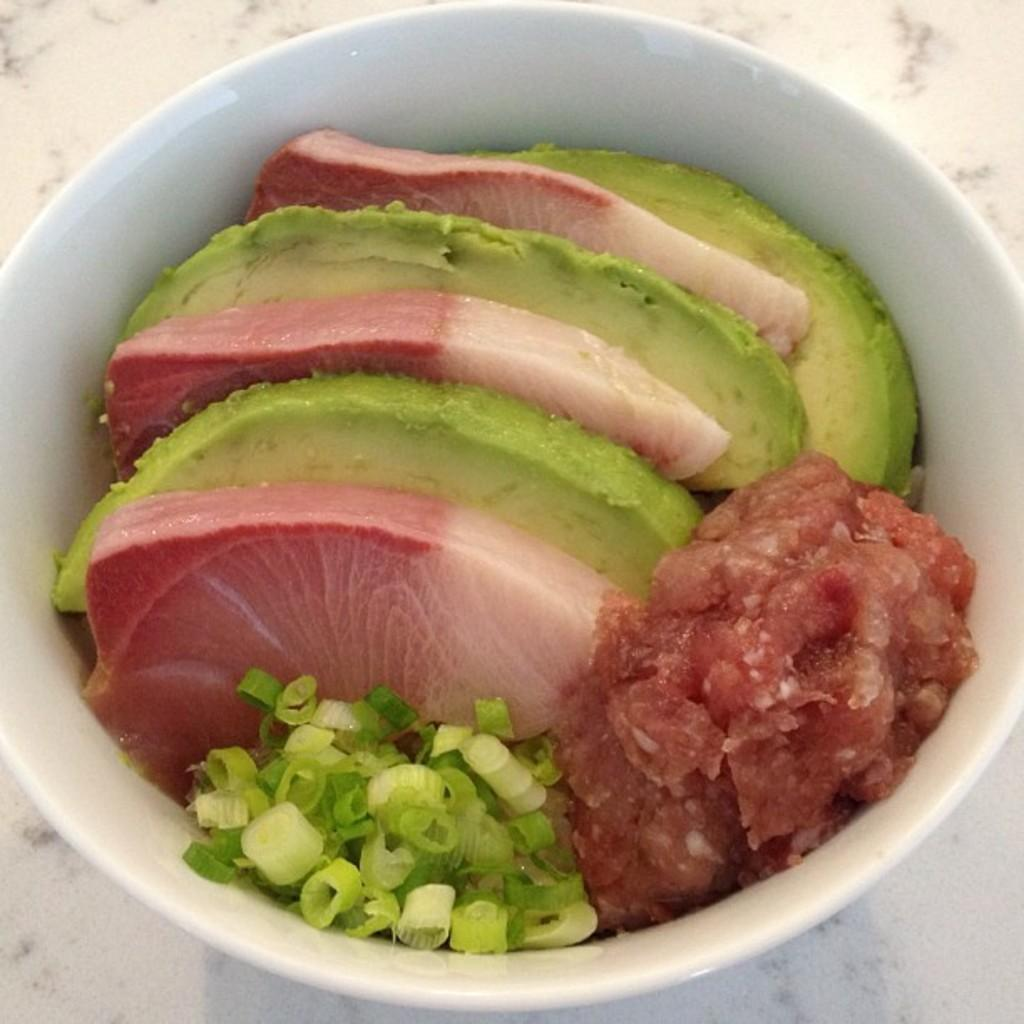What color is the bowl in the image? The bowl in the image is white. What is inside the white bowl? The bowl contains spring onions, meat, and green color eatables. What is the color of the table the bowl is placed on? The table is white. What type of skirt is being worn by the spring onions in the image? There are no people or clothing items, including skirts, present in the image. The image features a bowl containing spring onions, meat, and green color eatables. 